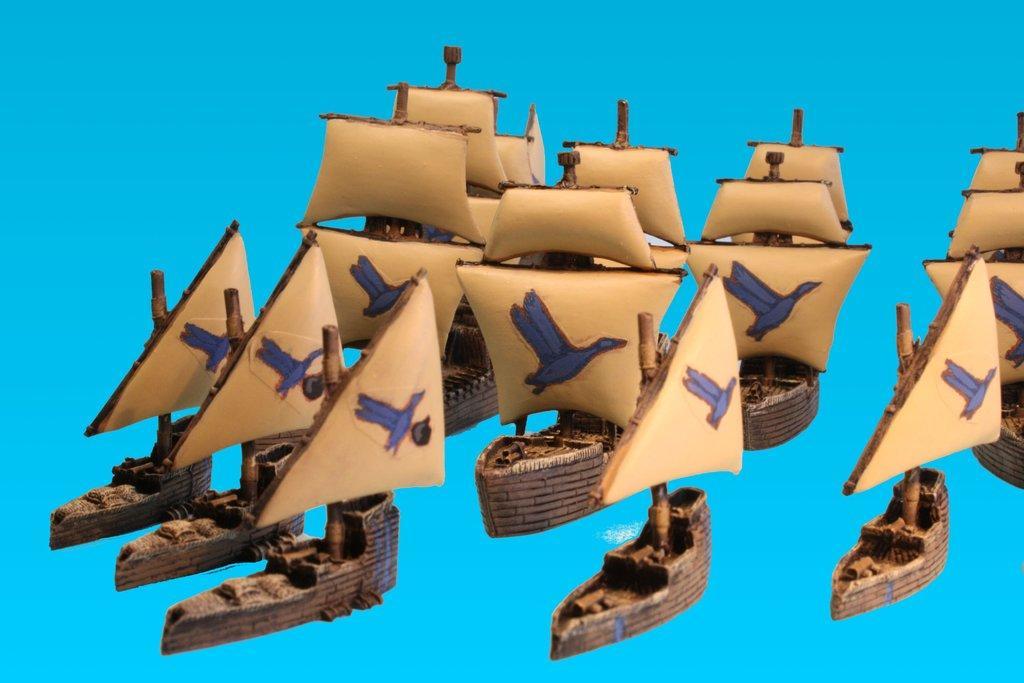How would you summarize this image in a sentence or two? In this image I can see depiction picture where I can see number of brown colour things. I can also see blue colour in the background. 